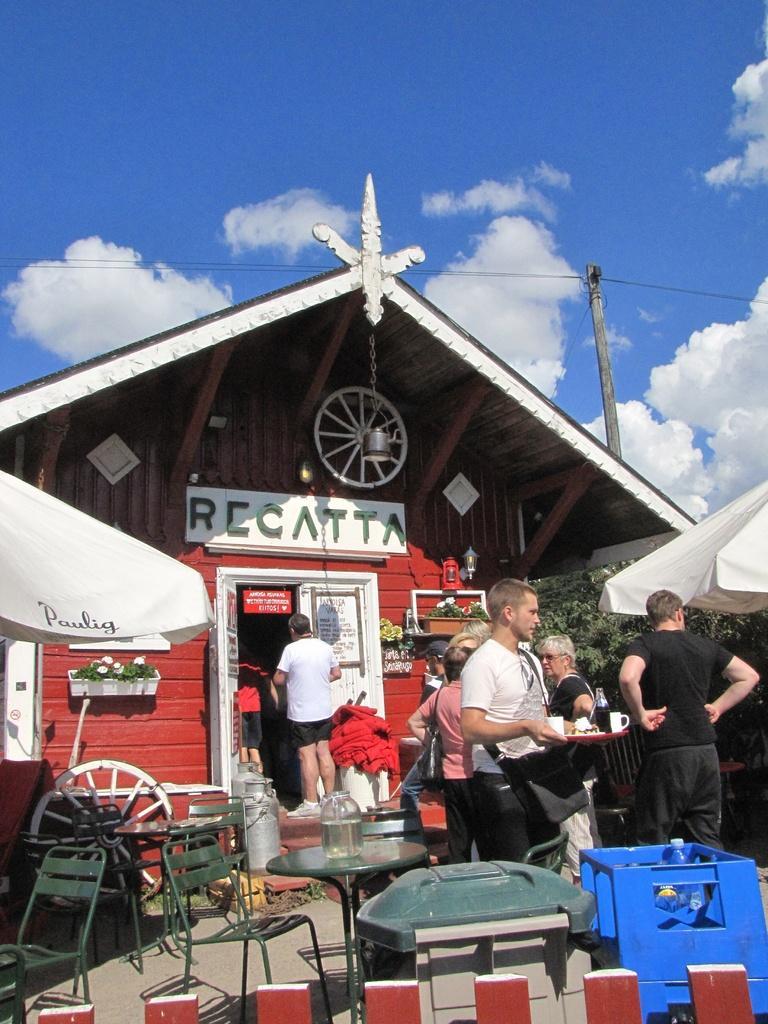Describe this image in one or two sentences. In this image in the front there is a wooden fence. In the center there are empty chairs, there are tables and there are objects which are green and blue in colour and there are persons standing and there are tents which are white in colour with some text written on it and there is a house and on the wall of the house there is some text. In the background there is a pole and on the pole there are wires and the sky is cloudy and there are trees and there are plants in front of the house. 